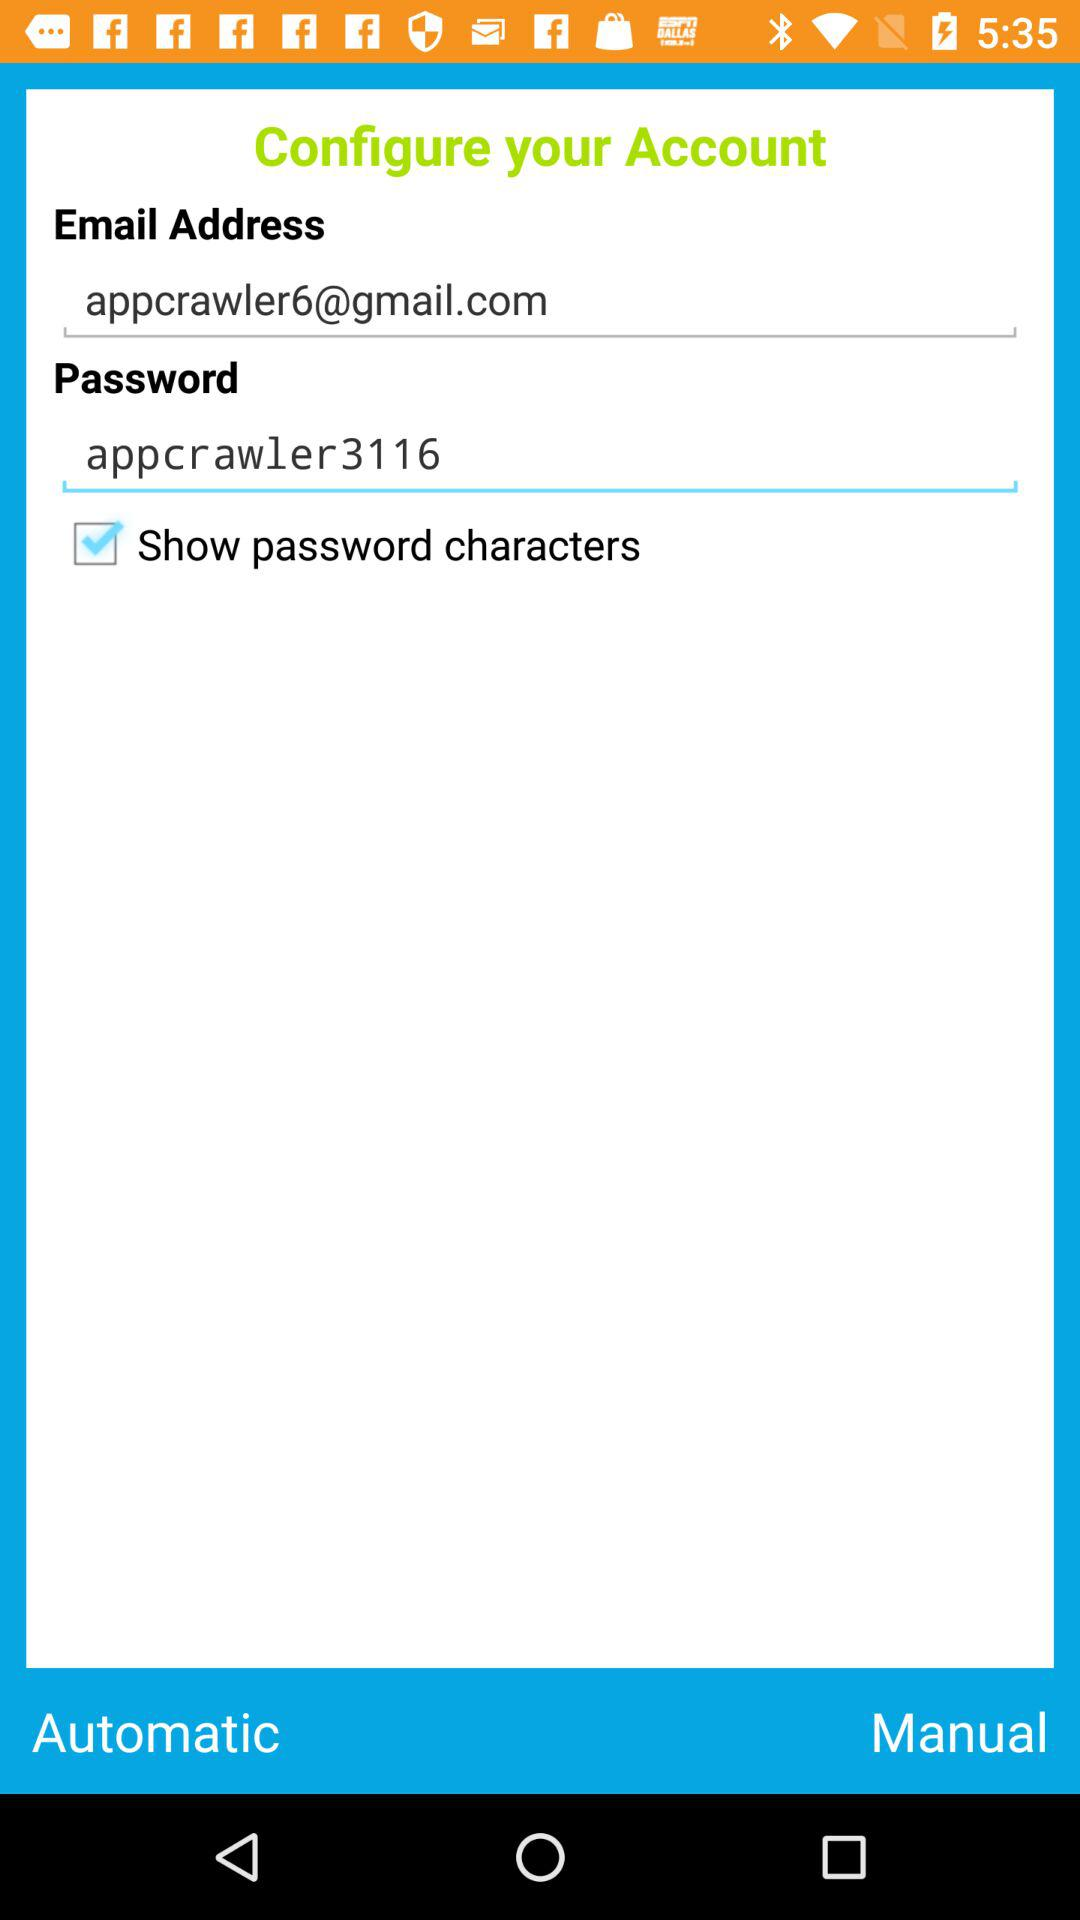What is the password? The password is "appcrawler3116". 